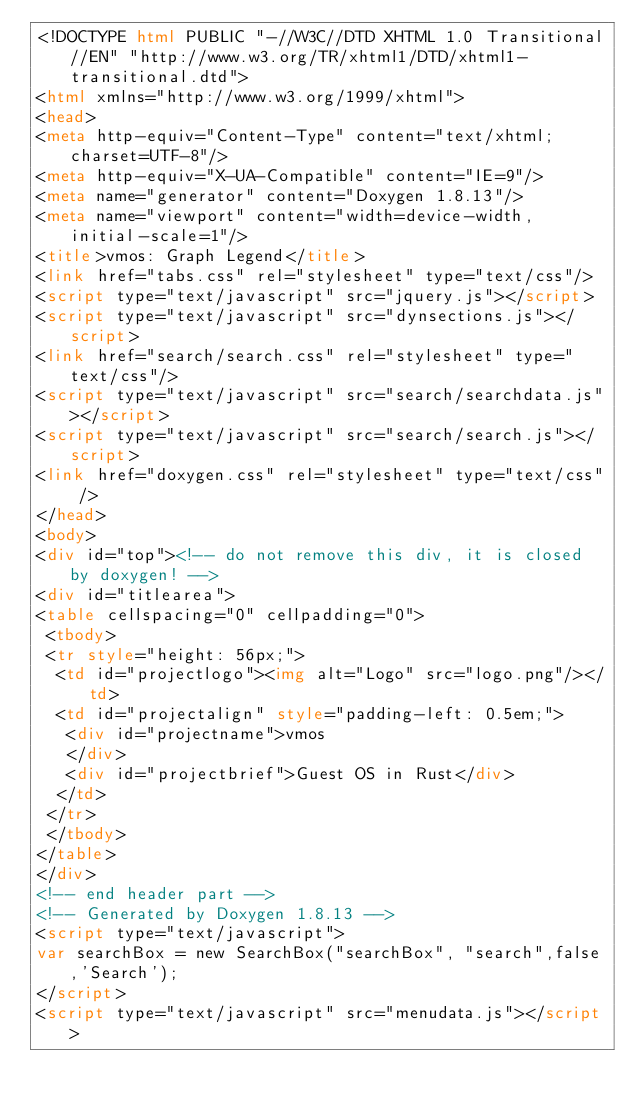<code> <loc_0><loc_0><loc_500><loc_500><_HTML_><!DOCTYPE html PUBLIC "-//W3C//DTD XHTML 1.0 Transitional//EN" "http://www.w3.org/TR/xhtml1/DTD/xhtml1-transitional.dtd">
<html xmlns="http://www.w3.org/1999/xhtml">
<head>
<meta http-equiv="Content-Type" content="text/xhtml;charset=UTF-8"/>
<meta http-equiv="X-UA-Compatible" content="IE=9"/>
<meta name="generator" content="Doxygen 1.8.13"/>
<meta name="viewport" content="width=device-width, initial-scale=1"/>
<title>vmos: Graph Legend</title>
<link href="tabs.css" rel="stylesheet" type="text/css"/>
<script type="text/javascript" src="jquery.js"></script>
<script type="text/javascript" src="dynsections.js"></script>
<link href="search/search.css" rel="stylesheet" type="text/css"/>
<script type="text/javascript" src="search/searchdata.js"></script>
<script type="text/javascript" src="search/search.js"></script>
<link href="doxygen.css" rel="stylesheet" type="text/css" />
</head>
<body>
<div id="top"><!-- do not remove this div, it is closed by doxygen! -->
<div id="titlearea">
<table cellspacing="0" cellpadding="0">
 <tbody>
 <tr style="height: 56px;">
  <td id="projectlogo"><img alt="Logo" src="logo.png"/></td>
  <td id="projectalign" style="padding-left: 0.5em;">
   <div id="projectname">vmos
   </div>
   <div id="projectbrief">Guest OS in Rust</div>
  </td>
 </tr>
 </tbody>
</table>
</div>
<!-- end header part -->
<!-- Generated by Doxygen 1.8.13 -->
<script type="text/javascript">
var searchBox = new SearchBox("searchBox", "search",false,'Search');
</script>
<script type="text/javascript" src="menudata.js"></script></code> 